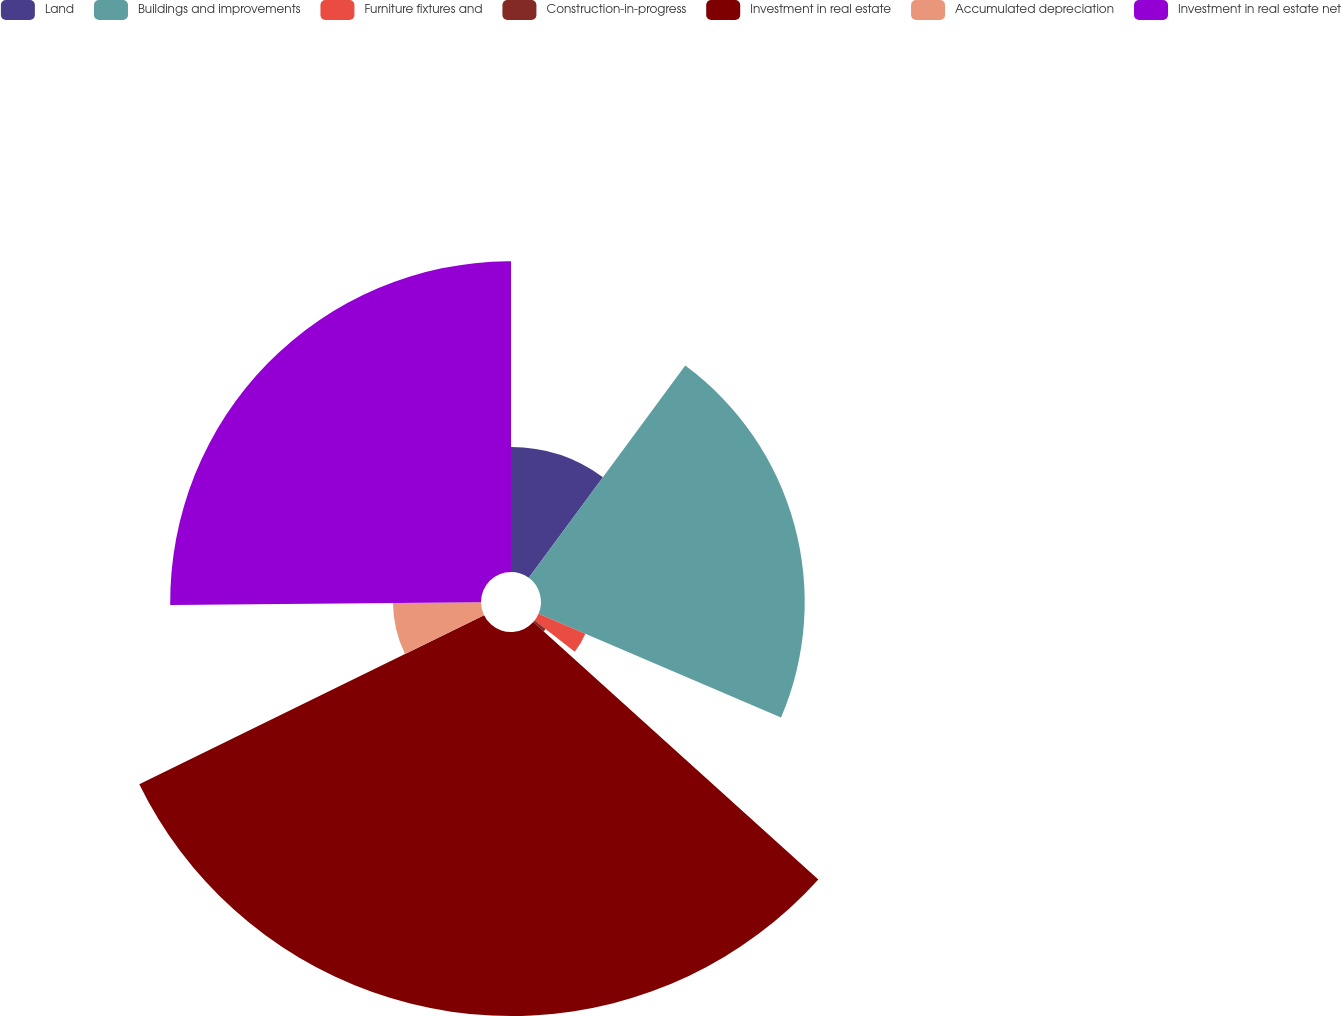Convert chart to OTSL. <chart><loc_0><loc_0><loc_500><loc_500><pie_chart><fcel>Land<fcel>Buildings and improvements<fcel>Furniture fixtures and<fcel>Construction-in-progress<fcel>Investment in real estate<fcel>Accumulated depreciation<fcel>Investment in real estate net<nl><fcel>10.11%<fcel>21.33%<fcel>4.12%<fcel>1.13%<fcel>31.06%<fcel>7.12%<fcel>25.14%<nl></chart> 